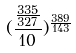<formula> <loc_0><loc_0><loc_500><loc_500>( \frac { \frac { 3 3 5 } { 3 2 7 } } { 1 0 } ) ^ { \frac { 3 8 9 } { 1 4 3 } }</formula> 